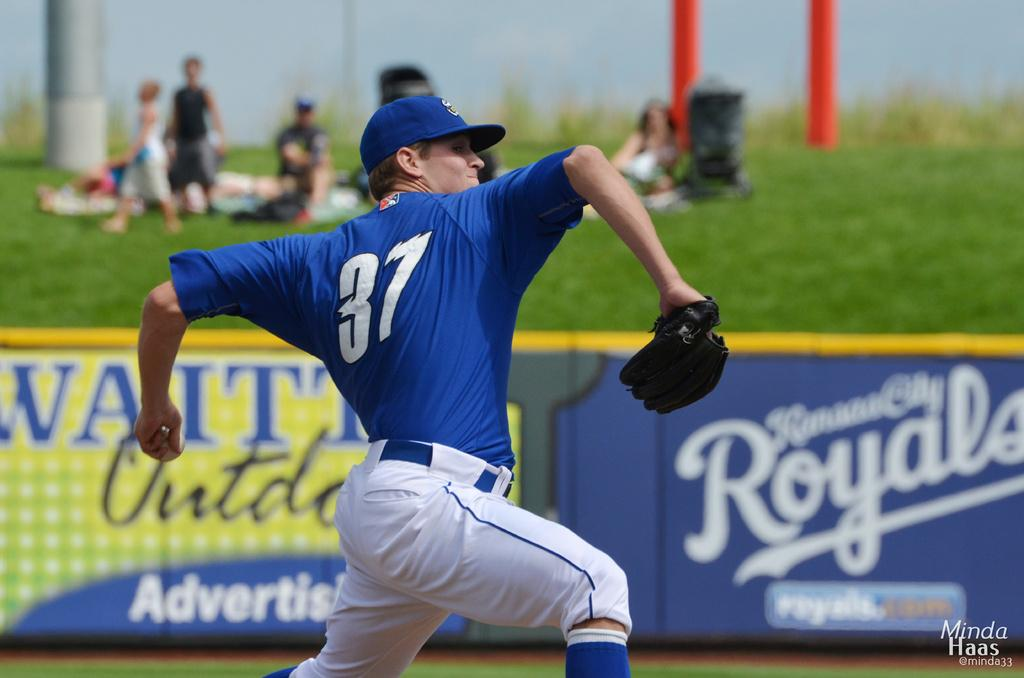<image>
Offer a succinct explanation of the picture presented. Baseball pitcher on the mound with a Royals sign in the background 